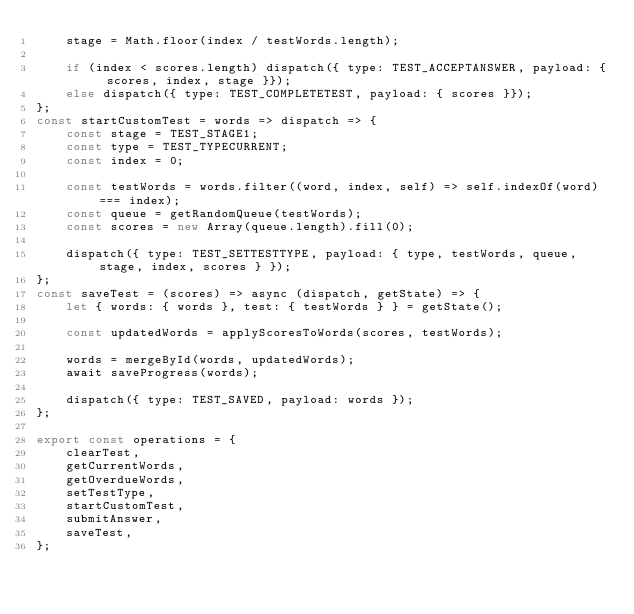Convert code to text. <code><loc_0><loc_0><loc_500><loc_500><_JavaScript_>    stage = Math.floor(index / testWords.length);

    if (index < scores.length) dispatch({ type: TEST_ACCEPTANSWER, payload: { scores, index, stage }});
    else dispatch({ type: TEST_COMPLETETEST, payload: { scores }});
};
const startCustomTest = words => dispatch => {
    const stage = TEST_STAGE1;
    const type = TEST_TYPECURRENT;
    const index = 0;

    const testWords = words.filter((word, index, self) => self.indexOf(word) === index);
    const queue = getRandomQueue(testWords);
    const scores = new Array(queue.length).fill(0);

    dispatch({ type: TEST_SETTESTTYPE, payload: { type, testWords, queue, stage, index, scores } });
};
const saveTest = (scores) => async (dispatch, getState) => {
    let { words: { words }, test: { testWords } } = getState();

    const updatedWords = applyScoresToWords(scores, testWords);

    words = mergeById(words, updatedWords);
    await saveProgress(words);

    dispatch({ type: TEST_SAVED, payload: words });
};

export const operations = {
    clearTest,
    getCurrentWords,
    getOverdueWords,
    setTestType,
    startCustomTest,
    submitAnswer,
    saveTest,
};</code> 